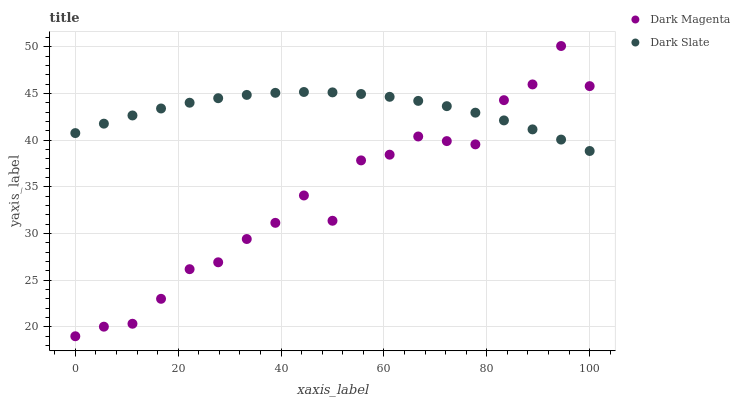Does Dark Magenta have the minimum area under the curve?
Answer yes or no. Yes. Does Dark Slate have the maximum area under the curve?
Answer yes or no. Yes. Does Dark Magenta have the maximum area under the curve?
Answer yes or no. No. Is Dark Slate the smoothest?
Answer yes or no. Yes. Is Dark Magenta the roughest?
Answer yes or no. Yes. Is Dark Magenta the smoothest?
Answer yes or no. No. Does Dark Magenta have the lowest value?
Answer yes or no. Yes. Does Dark Magenta have the highest value?
Answer yes or no. Yes. Does Dark Magenta intersect Dark Slate?
Answer yes or no. Yes. Is Dark Magenta less than Dark Slate?
Answer yes or no. No. Is Dark Magenta greater than Dark Slate?
Answer yes or no. No. 